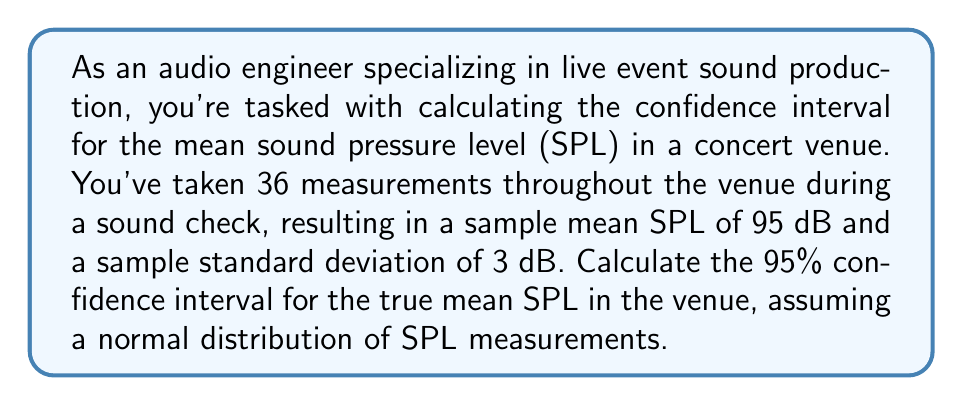Can you answer this question? To calculate the 95% confidence interval for the mean SPL, we'll follow these steps:

1. Identify the given information:
   - Sample size: $n = 36$
   - Sample mean: $\bar{x} = 95$ dB
   - Sample standard deviation: $s = 3$ dB
   - Confidence level: 95% (α = 0.05)

2. Determine the critical value:
   For a 95% confidence interval with df = 35, we use the t-distribution.
   The critical value is $t_{0.025, 35} = 2.030$ (from t-distribution table)

3. Calculate the margin of error:
   Margin of error = $t_{0.025, 35} \cdot \frac{s}{\sqrt{n}}$
   $$ \text{Margin of error} = 2.030 \cdot \frac{3}{\sqrt{36}} = 2.030 \cdot 0.5 = 1.015 $$

4. Calculate the confidence interval:
   $$ \text{CI} = \bar{x} \pm \text{Margin of error} $$
   $$ \text{CI} = 95 \pm 1.015 $$

5. Express the final confidence interval:
   $$ \text{95% CI} = (95 - 1.015, 95 + 1.015) = (93.985, 96.015) $$

Therefore, we can be 95% confident that the true mean SPL in the venue falls between 93.985 dB and 96.015 dB.
Answer: (93.985 dB, 96.015 dB) 